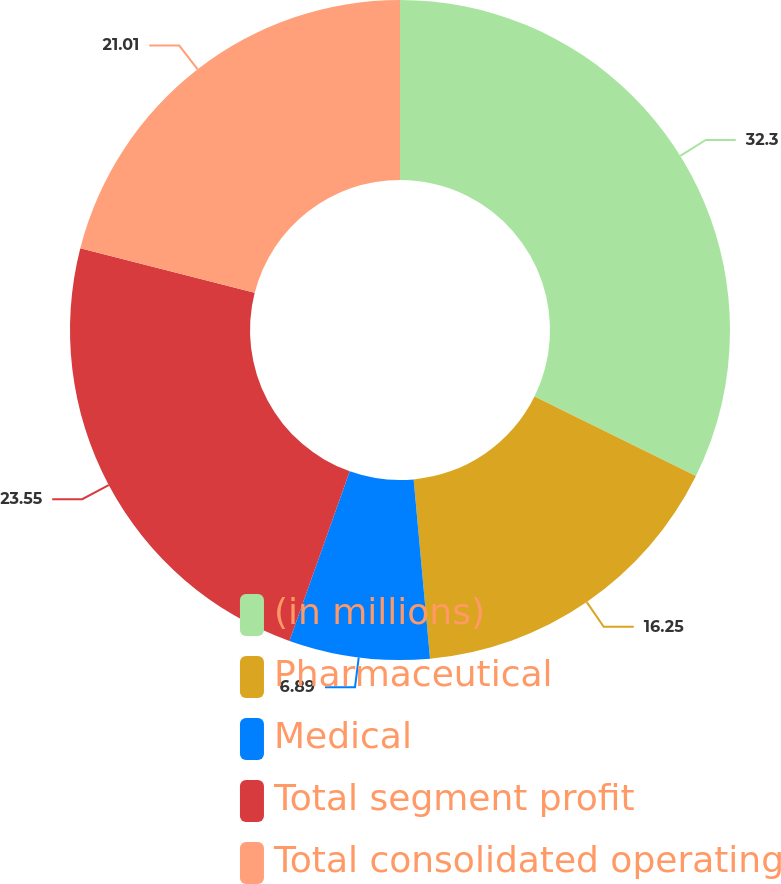<chart> <loc_0><loc_0><loc_500><loc_500><pie_chart><fcel>(in millions)<fcel>Pharmaceutical<fcel>Medical<fcel>Total segment profit<fcel>Total consolidated operating<nl><fcel>32.3%<fcel>16.25%<fcel>6.89%<fcel>23.55%<fcel>21.01%<nl></chart> 